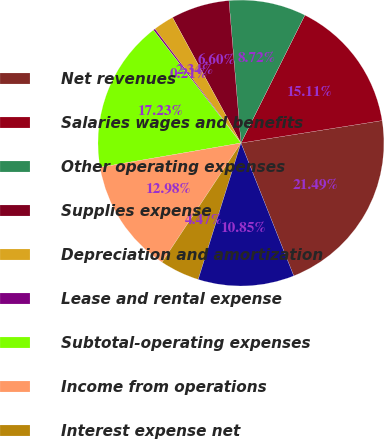Convert chart to OTSL. <chart><loc_0><loc_0><loc_500><loc_500><pie_chart><fcel>Net revenues<fcel>Salaries wages and benefits<fcel>Other operating expenses<fcel>Supplies expense<fcel>Depreciation and amortization<fcel>Lease and rental expense<fcel>Subtotal-operating expenses<fcel>Income from operations<fcel>Interest expense net<fcel>Income before income taxes<nl><fcel>21.49%<fcel>15.11%<fcel>8.72%<fcel>6.6%<fcel>2.34%<fcel>0.21%<fcel>17.23%<fcel>12.98%<fcel>4.47%<fcel>10.85%<nl></chart> 